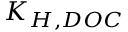<formula> <loc_0><loc_0><loc_500><loc_500>K _ { H , D O C }</formula> 